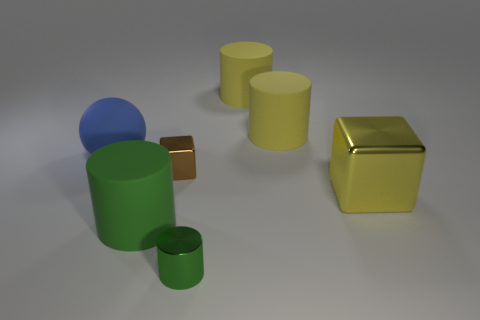Can you describe the largest object in the image? Certainly! The largest object in the image is a golden-yellow metal cube. Its reflective surface and sharp edges give it a sleek and polished appearance. 